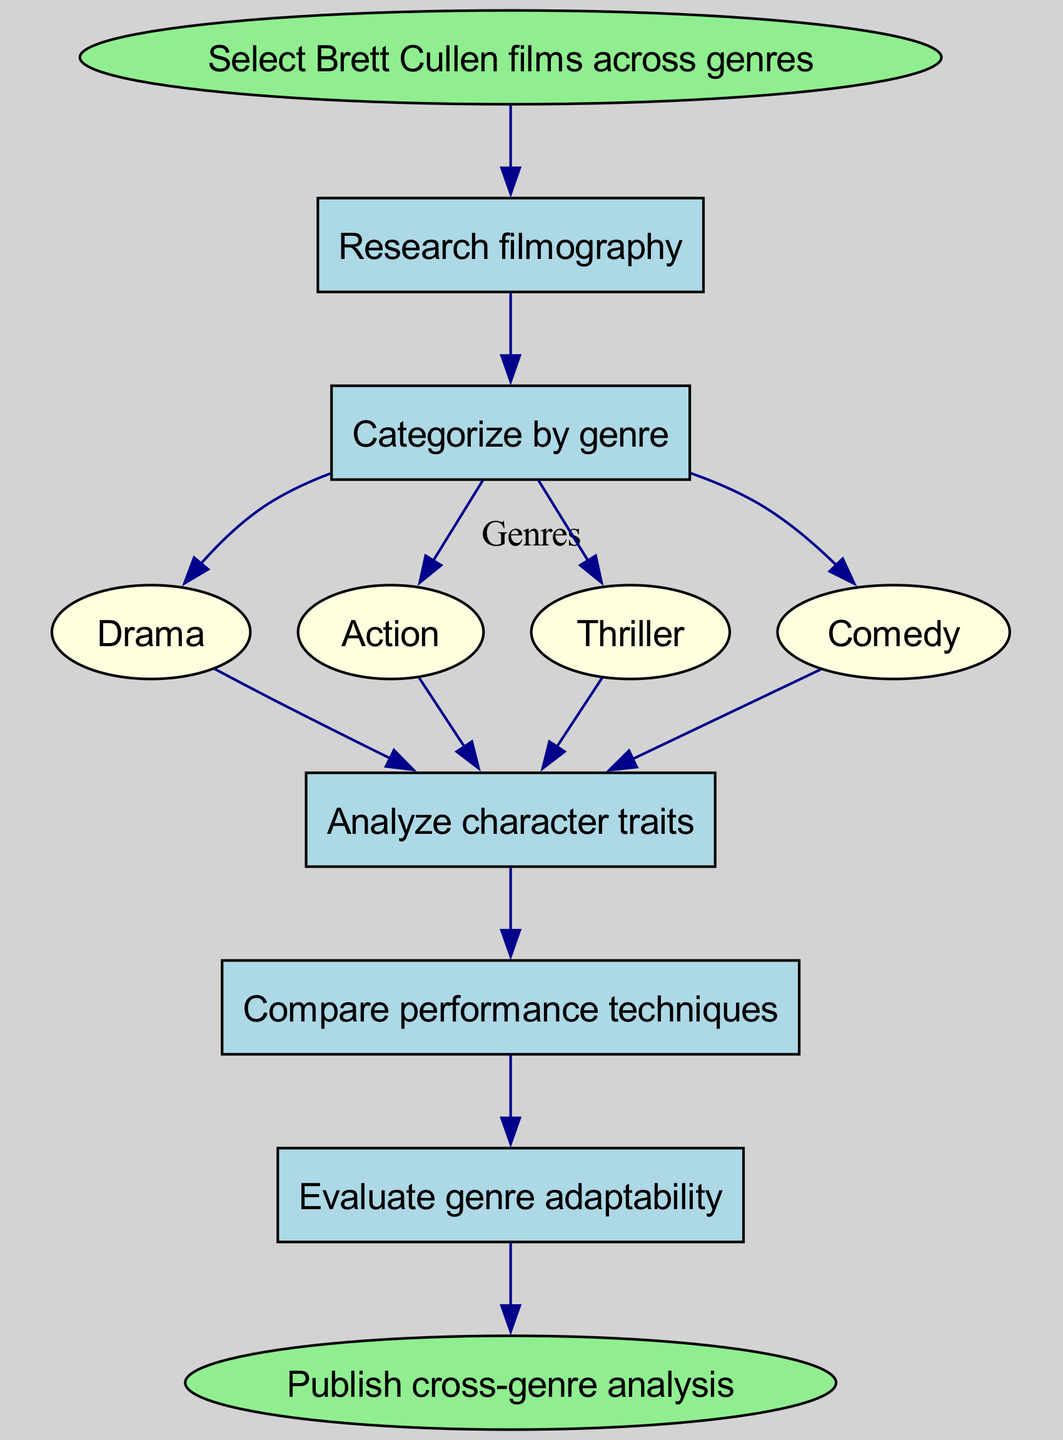What is the first step in the workflow? The diagram indicates that the first step is "Select Brett Cullen films across genres," which is explicitly stated as the starting point of the workflow.
Answer: Select Brett Cullen films across genres How many genres are identified in the workflow? The workflow categorizes films into four distinct genres: Drama, Action, Thriller, and Comedy. This information is available under the "Categorize by genre" step.
Answer: Four What is the last step before publishing the analysis? The last step before reaching the end of the workflow is "Write comparative review," which transitions to the final action of publishing the analysis.
Answer: Write comparative review What is the relationship between "Analyze character traits" and "Compare performance techniques"? The diagram shows a direct connection where "Analyze character traits" leads to "Compare performance techniques," indicating a sequential flow from one step to the next in the workflow.
Answer: Sequential flow Which genre follows the "Categorize by genre" step? The workflow continues to "Analyze character traits" immediately after the "Categorize by genre" step, making this the next stage in the process following genre categorization.
Answer: Analyze character traits Which step includes options for different genres? The "Categorize by genre" step explicitly includes options for Drama, Action, Thriller, and Comedy, showcasing the various genres that Brett Cullen's films can be categorized into.
Answer: Categorize by genre How does the workflow conclude? The process concludes with the final node labeled "Publish cross-genre analysis," which indicates that the workflow culminates in the action of sharing the comparative analysis.
Answer: Publish cross-genre analysis What is the purpose of evaluating genre adaptability? The step "Evaluate genre adaptability" serves to assess how well Brett Cullen's performances can adapt across various genres, which is a critical part of the comparative analysis.
Answer: Assess adaptability 